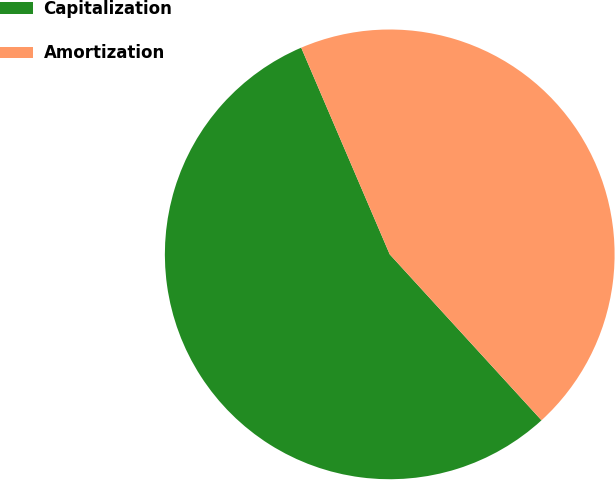Convert chart. <chart><loc_0><loc_0><loc_500><loc_500><pie_chart><fcel>Capitalization<fcel>Amortization<nl><fcel>55.35%<fcel>44.65%<nl></chart> 